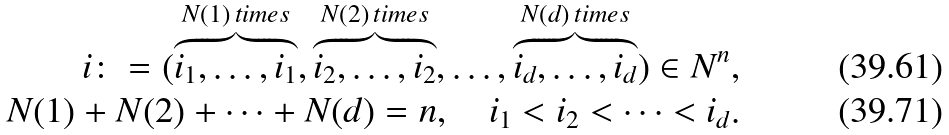Convert formula to latex. <formula><loc_0><loc_0><loc_500><loc_500>i \colon = ( \overbrace { i _ { 1 } , \dots , i _ { 1 } } ^ { N ( 1 ) \, t i m e s } , \overbrace { i _ { 2 } , \dots , i _ { 2 } } ^ { N ( 2 ) \, t i m e s } , \dots , \overbrace { i _ { d } , \dots , i _ { d } } ^ { N ( d ) \, t i m e s } ) \in N ^ { n } , \\ N ( 1 ) + N ( 2 ) + \dots + N ( d ) = n , \quad i _ { 1 } < i _ { 2 } < \dots < i _ { d } .</formula> 